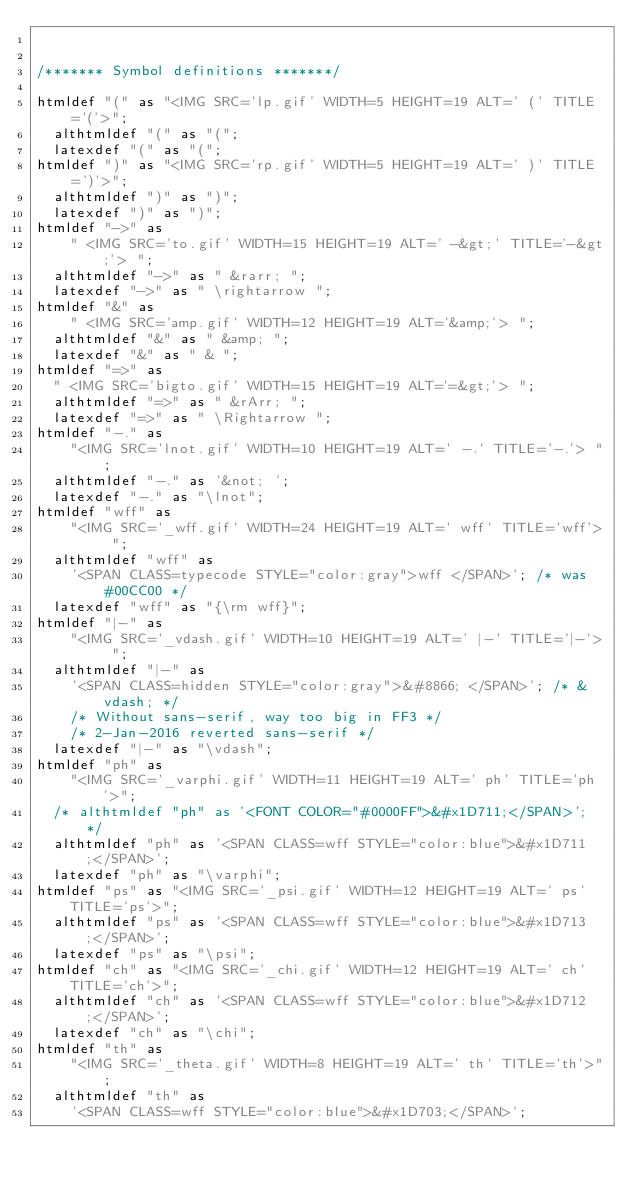Convert code to text. <code><loc_0><loc_0><loc_500><loc_500><_ObjectiveC_>

/******* Symbol definitions *******/

htmldef "(" as "<IMG SRC='lp.gif' WIDTH=5 HEIGHT=19 ALT=' (' TITLE='('>";
  althtmldef "(" as "(";
  latexdef "(" as "(";
htmldef ")" as "<IMG SRC='rp.gif' WIDTH=5 HEIGHT=19 ALT=' )' TITLE=')'>";
  althtmldef ")" as ")";
  latexdef ")" as ")";
htmldef "->" as
    " <IMG SRC='to.gif' WIDTH=15 HEIGHT=19 ALT=' -&gt;' TITLE='-&gt;'> ";
  althtmldef "->" as " &rarr; ";
  latexdef "->" as " \rightarrow ";
htmldef "&" as
    " <IMG SRC='amp.gif' WIDTH=12 HEIGHT=19 ALT='&amp;'> ";
  althtmldef "&" as " &amp; ";
  latexdef "&" as " & ";
htmldef "=>" as
  " <IMG SRC='bigto.gif' WIDTH=15 HEIGHT=19 ALT='=&gt;'> ";
  althtmldef "=>" as " &rArr; ";
  latexdef "=>" as " \Rightarrow ";
htmldef "-." as
    "<IMG SRC='lnot.gif' WIDTH=10 HEIGHT=19 ALT=' -.' TITLE='-.'> ";
  althtmldef "-." as '&not; ';
  latexdef "-." as "\lnot";
htmldef "wff" as
    "<IMG SRC='_wff.gif' WIDTH=24 HEIGHT=19 ALT=' wff' TITLE='wff'> ";
  althtmldef "wff" as
    '<SPAN CLASS=typecode STYLE="color:gray">wff </SPAN>'; /* was #00CC00 */
  latexdef "wff" as "{\rm wff}";
htmldef "|-" as
    "<IMG SRC='_vdash.gif' WIDTH=10 HEIGHT=19 ALT=' |-' TITLE='|-'> ";
  althtmldef "|-" as
    '<SPAN CLASS=hidden STYLE="color:gray">&#8866; </SPAN>'; /* &vdash; */
    /* Without sans-serif, way too big in FF3 */
    /* 2-Jan-2016 reverted sans-serif */
  latexdef "|-" as "\vdash";
htmldef "ph" as
    "<IMG SRC='_varphi.gif' WIDTH=11 HEIGHT=19 ALT=' ph' TITLE='ph'>";
  /* althtmldef "ph" as '<FONT COLOR="#0000FF">&#x1D711;</SPAN>'; */
  althtmldef "ph" as '<SPAN CLASS=wff STYLE="color:blue">&#x1D711;</SPAN>';
  latexdef "ph" as "\varphi";
htmldef "ps" as "<IMG SRC='_psi.gif' WIDTH=12 HEIGHT=19 ALT=' ps' TITLE='ps'>";
  althtmldef "ps" as '<SPAN CLASS=wff STYLE="color:blue">&#x1D713;</SPAN>';
  latexdef "ps" as "\psi";
htmldef "ch" as "<IMG SRC='_chi.gif' WIDTH=12 HEIGHT=19 ALT=' ch' TITLE='ch'>";
  althtmldef "ch" as '<SPAN CLASS=wff STYLE="color:blue">&#x1D712;</SPAN>';
  latexdef "ch" as "\chi";
htmldef "th" as
    "<IMG SRC='_theta.gif' WIDTH=8 HEIGHT=19 ALT=' th' TITLE='th'>";
  althtmldef "th" as
    '<SPAN CLASS=wff STYLE="color:blue">&#x1D703;</SPAN>';</code> 